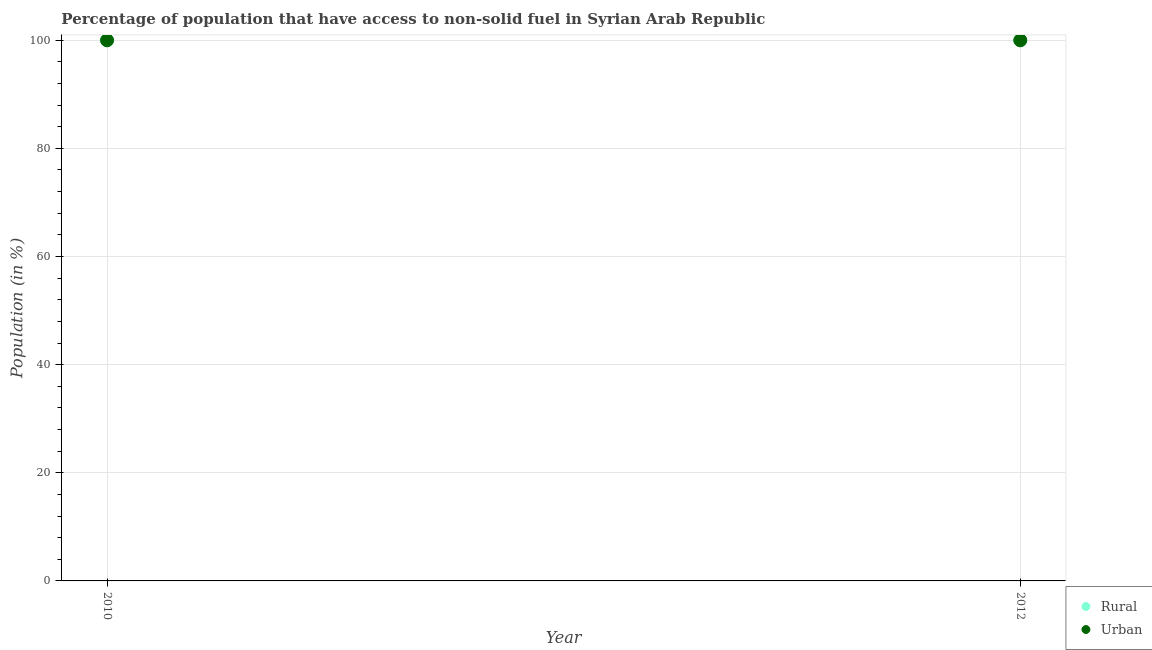What is the rural population in 2012?
Provide a short and direct response. 99.99. Across all years, what is the maximum urban population?
Offer a very short reply. 99.99. Across all years, what is the minimum rural population?
Your answer should be very brief. 99.99. What is the total rural population in the graph?
Ensure brevity in your answer.  199.98. What is the difference between the urban population in 2010 and the rural population in 2012?
Your response must be concise. 0. What is the average urban population per year?
Your answer should be very brief. 99.99. What is the ratio of the urban population in 2010 to that in 2012?
Offer a terse response. 1. Is the rural population strictly greater than the urban population over the years?
Ensure brevity in your answer.  No. How many years are there in the graph?
Offer a very short reply. 2. Does the graph contain grids?
Your answer should be compact. Yes. How many legend labels are there?
Your answer should be very brief. 2. What is the title of the graph?
Provide a short and direct response. Percentage of population that have access to non-solid fuel in Syrian Arab Republic. What is the Population (in %) of Rural in 2010?
Offer a terse response. 99.99. What is the Population (in %) in Urban in 2010?
Provide a short and direct response. 99.99. What is the Population (in %) of Rural in 2012?
Your answer should be compact. 99.99. What is the Population (in %) of Urban in 2012?
Offer a very short reply. 99.99. Across all years, what is the maximum Population (in %) of Rural?
Provide a short and direct response. 99.99. Across all years, what is the maximum Population (in %) in Urban?
Your answer should be compact. 99.99. Across all years, what is the minimum Population (in %) of Rural?
Your answer should be very brief. 99.99. Across all years, what is the minimum Population (in %) of Urban?
Keep it short and to the point. 99.99. What is the total Population (in %) in Rural in the graph?
Ensure brevity in your answer.  199.98. What is the total Population (in %) in Urban in the graph?
Provide a short and direct response. 199.98. What is the difference between the Population (in %) in Rural in 2010 and the Population (in %) in Urban in 2012?
Keep it short and to the point. 0. What is the average Population (in %) of Rural per year?
Your answer should be very brief. 99.99. What is the average Population (in %) in Urban per year?
Your answer should be compact. 99.99. What is the ratio of the Population (in %) in Rural in 2010 to that in 2012?
Your answer should be very brief. 1. What is the difference between the highest and the lowest Population (in %) of Rural?
Ensure brevity in your answer.  0. 